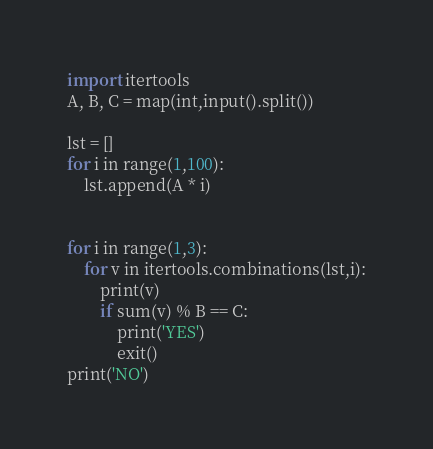<code> <loc_0><loc_0><loc_500><loc_500><_Python_>import itertools
A, B, C = map(int,input().split())

lst = []
for i in range(1,100):
    lst.append(A * i)


for i in range(1,3):
    for v in itertools.combinations(lst,i):
        print(v)
        if sum(v) % B == C:
            print('YES')
            exit()
print('NO')</code> 